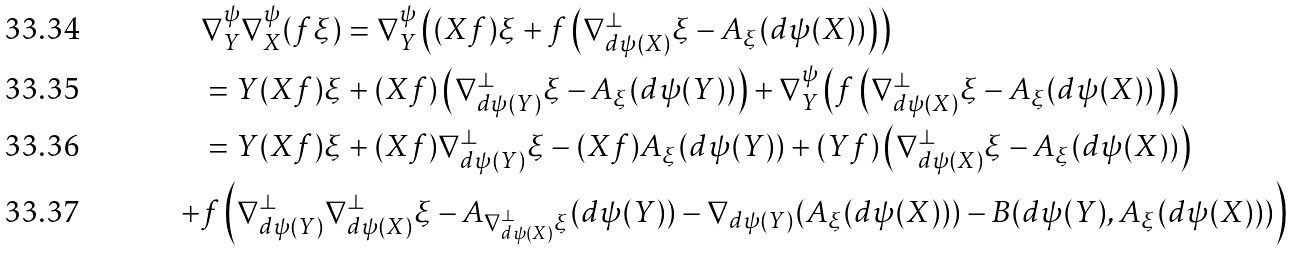Convert formula to latex. <formula><loc_0><loc_0><loc_500><loc_500>& \nabla ^ { \psi } _ { Y } \nabla ^ { \psi } _ { X } ( f \xi ) = \nabla ^ { \psi } _ { Y } \left ( ( X f ) \xi + f \left ( \nabla ^ { \perp } _ { d \psi ( X ) } \xi - A _ { \xi } ( d \psi ( X ) ) \right ) \right ) \\ & = Y ( X f ) \xi + ( X f ) \left ( \nabla ^ { \perp } _ { d \psi ( Y ) } \xi - A _ { \xi } ( d \psi ( Y ) ) \right ) + \nabla ^ { \psi } _ { Y } \left ( f \left ( \nabla ^ { \perp } _ { d \psi ( X ) } \xi - A _ { \xi } ( d \psi ( X ) ) \right ) \right ) \\ & = Y ( X f ) \xi + ( X f ) \nabla ^ { \perp } _ { d \psi ( Y ) } \xi - ( X f ) A _ { \xi } ( d \psi ( Y ) ) + ( Y f ) \left ( \nabla ^ { \perp } _ { d \psi ( X ) } \xi - A _ { \xi } ( d \psi ( X ) ) \right ) \\ + & f \left ( \nabla ^ { \perp } _ { d \psi ( Y ) } \nabla ^ { \perp } _ { d \psi ( X ) } \xi - A _ { \nabla ^ { \perp } _ { d \psi ( X ) } \xi } ( d \psi ( Y ) ) - \nabla _ { d \psi ( Y ) } ( A _ { \xi } ( d \psi ( X ) ) ) - B ( d \psi ( Y ) , A _ { \xi } ( d \psi ( X ) ) ) \right )</formula> 